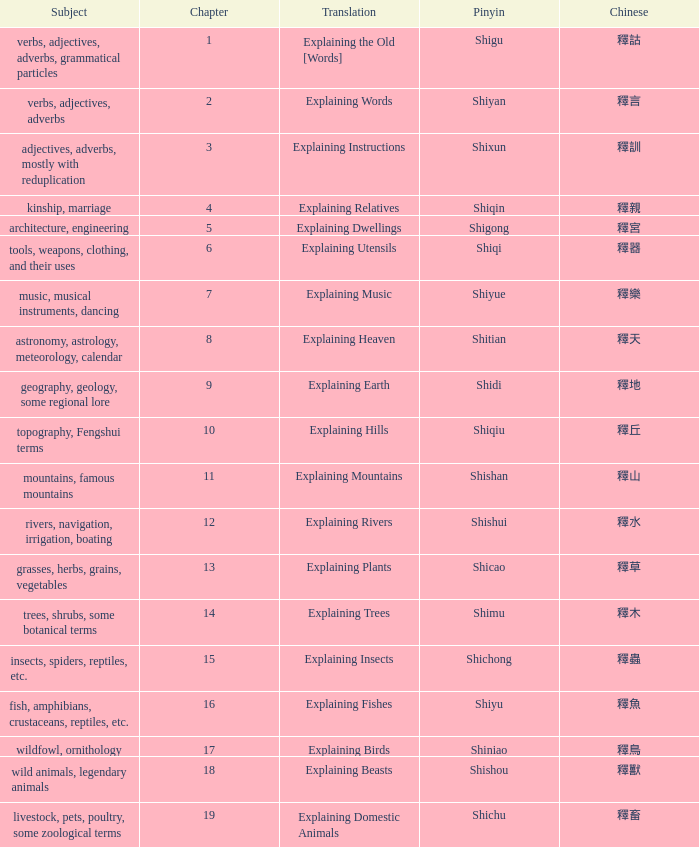Name the chapter with chinese of 釋水 12.0. 